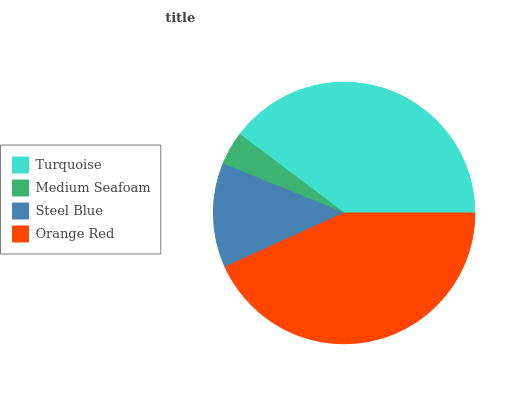Is Medium Seafoam the minimum?
Answer yes or no. Yes. Is Orange Red the maximum?
Answer yes or no. Yes. Is Steel Blue the minimum?
Answer yes or no. No. Is Steel Blue the maximum?
Answer yes or no. No. Is Steel Blue greater than Medium Seafoam?
Answer yes or no. Yes. Is Medium Seafoam less than Steel Blue?
Answer yes or no. Yes. Is Medium Seafoam greater than Steel Blue?
Answer yes or no. No. Is Steel Blue less than Medium Seafoam?
Answer yes or no. No. Is Turquoise the high median?
Answer yes or no. Yes. Is Steel Blue the low median?
Answer yes or no. Yes. Is Medium Seafoam the high median?
Answer yes or no. No. Is Orange Red the low median?
Answer yes or no. No. 